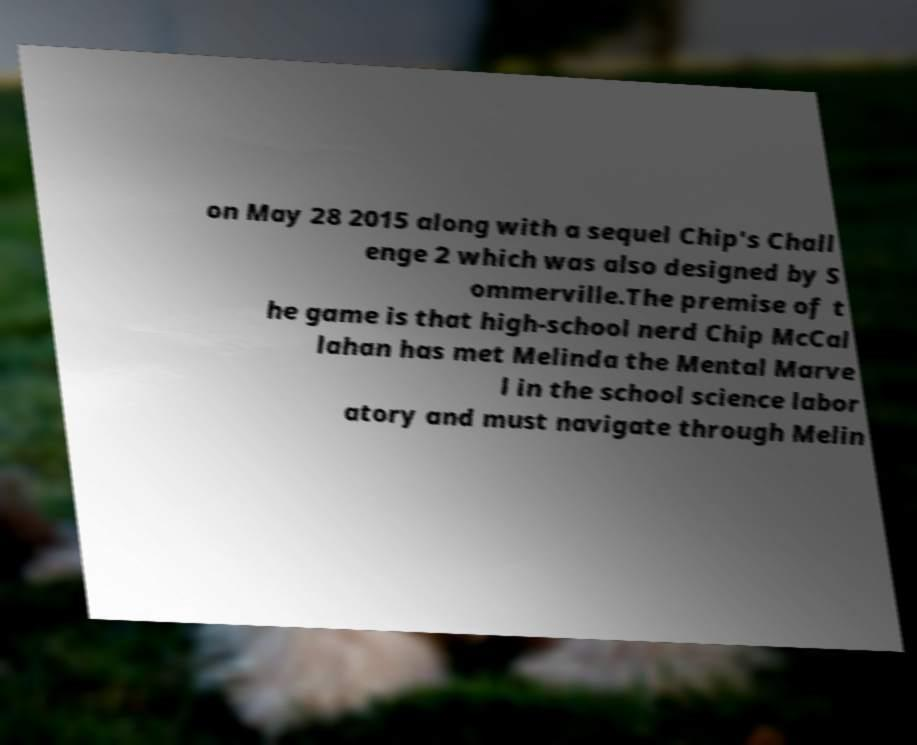Please identify and transcribe the text found in this image. on May 28 2015 along with a sequel Chip's Chall enge 2 which was also designed by S ommerville.The premise of t he game is that high-school nerd Chip McCal lahan has met Melinda the Mental Marve l in the school science labor atory and must navigate through Melin 